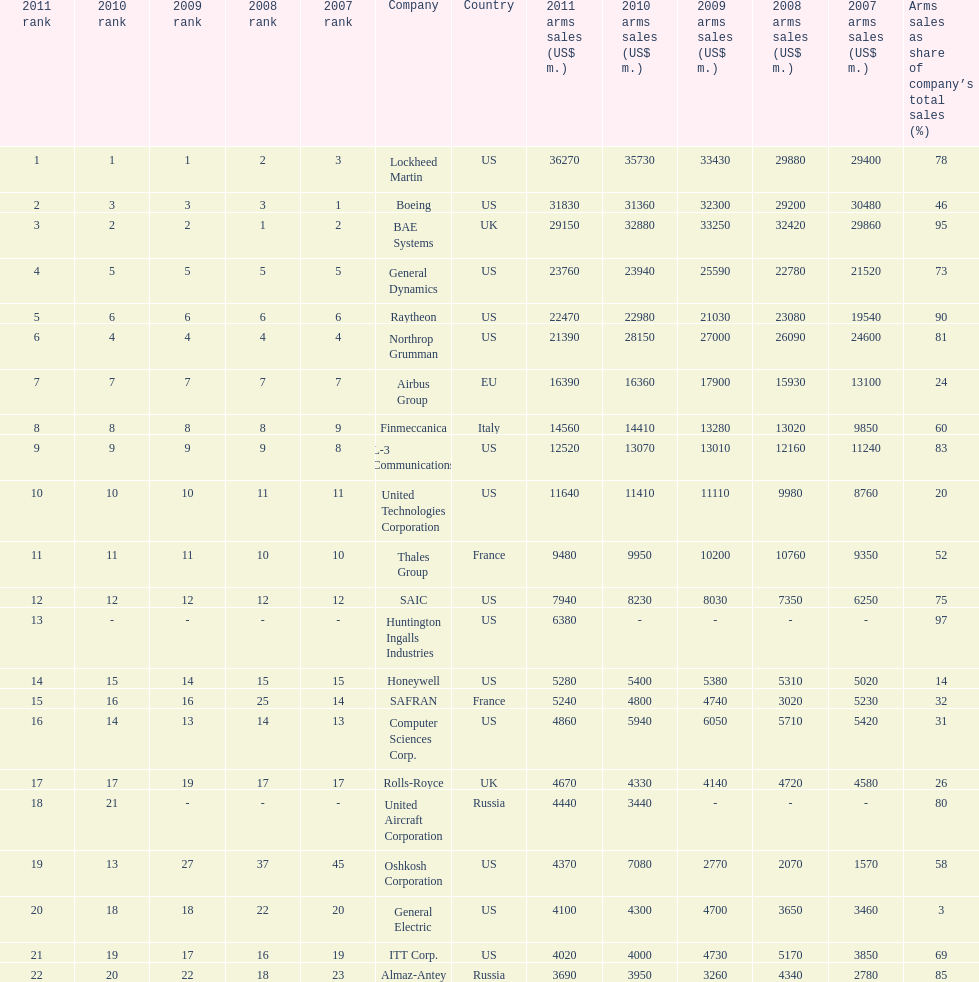What country is the first listed country? USA. 